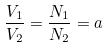<formula> <loc_0><loc_0><loc_500><loc_500>\frac { V _ { 1 } } { V _ { 2 } } = \frac { N _ { 1 } } { N _ { 2 } } = a</formula> 